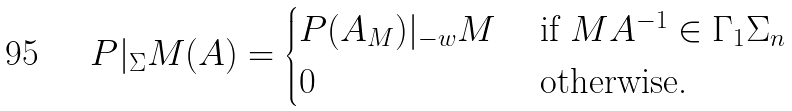<formula> <loc_0><loc_0><loc_500><loc_500>P | _ { \Sigma } M ( A ) = \begin{cases} P ( A _ { M } ) | _ { - w } M & \text { if } M A ^ { - 1 } \in \Gamma _ { 1 } \Sigma _ { n } \\ 0 & \text { otherwise.} \end{cases}</formula> 